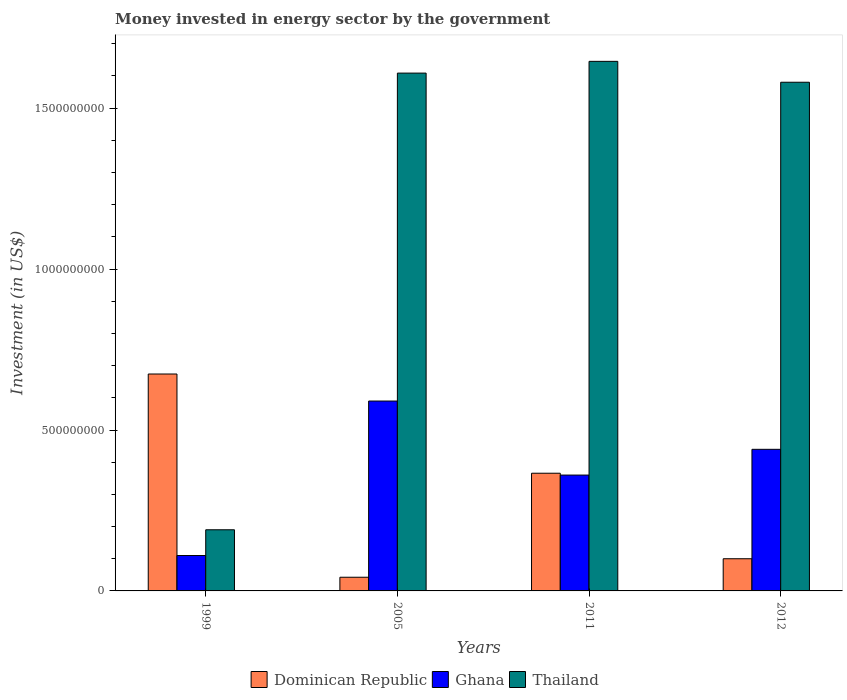How many different coloured bars are there?
Ensure brevity in your answer.  3. How many groups of bars are there?
Make the answer very short. 4. Are the number of bars on each tick of the X-axis equal?
Your response must be concise. Yes. In how many cases, is the number of bars for a given year not equal to the number of legend labels?
Make the answer very short. 0. What is the money spent in energy sector in Thailand in 1999?
Keep it short and to the point. 1.90e+08. Across all years, what is the maximum money spent in energy sector in Ghana?
Your answer should be compact. 5.90e+08. Across all years, what is the minimum money spent in energy sector in Dominican Republic?
Provide a succinct answer. 4.25e+07. In which year was the money spent in energy sector in Dominican Republic minimum?
Offer a very short reply. 2005. What is the total money spent in energy sector in Thailand in the graph?
Keep it short and to the point. 5.03e+09. What is the difference between the money spent in energy sector in Thailand in 2005 and that in 2011?
Provide a short and direct response. -3.65e+07. What is the difference between the money spent in energy sector in Thailand in 2011 and the money spent in energy sector in Dominican Republic in 2012?
Make the answer very short. 1.55e+09. What is the average money spent in energy sector in Ghana per year?
Make the answer very short. 3.75e+08. In the year 2012, what is the difference between the money spent in energy sector in Ghana and money spent in energy sector in Dominican Republic?
Give a very brief answer. 3.40e+08. What is the ratio of the money spent in energy sector in Ghana in 2011 to that in 2012?
Give a very brief answer. 0.82. Is the money spent in energy sector in Dominican Republic in 2005 less than that in 2011?
Make the answer very short. Yes. What is the difference between the highest and the second highest money spent in energy sector in Dominican Republic?
Ensure brevity in your answer.  3.08e+08. What is the difference between the highest and the lowest money spent in energy sector in Ghana?
Ensure brevity in your answer.  4.80e+08. Is the sum of the money spent in energy sector in Thailand in 1999 and 2011 greater than the maximum money spent in energy sector in Ghana across all years?
Give a very brief answer. Yes. What does the 3rd bar from the left in 1999 represents?
Your answer should be compact. Thailand. What does the 1st bar from the right in 2012 represents?
Your answer should be compact. Thailand. Are all the bars in the graph horizontal?
Keep it short and to the point. No. How many years are there in the graph?
Give a very brief answer. 4. What is the difference between two consecutive major ticks on the Y-axis?
Keep it short and to the point. 5.00e+08. Does the graph contain grids?
Your answer should be compact. No. Where does the legend appear in the graph?
Your answer should be compact. Bottom center. How many legend labels are there?
Provide a succinct answer. 3. What is the title of the graph?
Provide a succinct answer. Money invested in energy sector by the government. Does "Montenegro" appear as one of the legend labels in the graph?
Provide a short and direct response. No. What is the label or title of the Y-axis?
Your answer should be compact. Investment (in US$). What is the Investment (in US$) of Dominican Republic in 1999?
Ensure brevity in your answer.  6.74e+08. What is the Investment (in US$) of Ghana in 1999?
Offer a terse response. 1.10e+08. What is the Investment (in US$) of Thailand in 1999?
Ensure brevity in your answer.  1.90e+08. What is the Investment (in US$) of Dominican Republic in 2005?
Keep it short and to the point. 4.25e+07. What is the Investment (in US$) in Ghana in 2005?
Provide a succinct answer. 5.90e+08. What is the Investment (in US$) of Thailand in 2005?
Your answer should be compact. 1.61e+09. What is the Investment (in US$) in Dominican Republic in 2011?
Provide a short and direct response. 3.66e+08. What is the Investment (in US$) of Ghana in 2011?
Offer a terse response. 3.60e+08. What is the Investment (in US$) of Thailand in 2011?
Your response must be concise. 1.65e+09. What is the Investment (in US$) of Ghana in 2012?
Offer a very short reply. 4.40e+08. What is the Investment (in US$) in Thailand in 2012?
Offer a very short reply. 1.58e+09. Across all years, what is the maximum Investment (in US$) of Dominican Republic?
Your response must be concise. 6.74e+08. Across all years, what is the maximum Investment (in US$) in Ghana?
Keep it short and to the point. 5.90e+08. Across all years, what is the maximum Investment (in US$) of Thailand?
Your answer should be compact. 1.65e+09. Across all years, what is the minimum Investment (in US$) in Dominican Republic?
Give a very brief answer. 4.25e+07. Across all years, what is the minimum Investment (in US$) in Ghana?
Provide a succinct answer. 1.10e+08. Across all years, what is the minimum Investment (in US$) in Thailand?
Ensure brevity in your answer.  1.90e+08. What is the total Investment (in US$) in Dominican Republic in the graph?
Your answer should be compact. 1.18e+09. What is the total Investment (in US$) in Ghana in the graph?
Provide a succinct answer. 1.50e+09. What is the total Investment (in US$) of Thailand in the graph?
Give a very brief answer. 5.03e+09. What is the difference between the Investment (in US$) of Dominican Republic in 1999 and that in 2005?
Your response must be concise. 6.32e+08. What is the difference between the Investment (in US$) in Ghana in 1999 and that in 2005?
Offer a terse response. -4.80e+08. What is the difference between the Investment (in US$) in Thailand in 1999 and that in 2005?
Your answer should be very brief. -1.42e+09. What is the difference between the Investment (in US$) in Dominican Republic in 1999 and that in 2011?
Keep it short and to the point. 3.08e+08. What is the difference between the Investment (in US$) of Ghana in 1999 and that in 2011?
Give a very brief answer. -2.50e+08. What is the difference between the Investment (in US$) of Thailand in 1999 and that in 2011?
Give a very brief answer. -1.46e+09. What is the difference between the Investment (in US$) of Dominican Republic in 1999 and that in 2012?
Ensure brevity in your answer.  5.74e+08. What is the difference between the Investment (in US$) of Ghana in 1999 and that in 2012?
Keep it short and to the point. -3.30e+08. What is the difference between the Investment (in US$) of Thailand in 1999 and that in 2012?
Give a very brief answer. -1.39e+09. What is the difference between the Investment (in US$) in Dominican Republic in 2005 and that in 2011?
Your answer should be compact. -3.23e+08. What is the difference between the Investment (in US$) in Ghana in 2005 and that in 2011?
Ensure brevity in your answer.  2.30e+08. What is the difference between the Investment (in US$) of Thailand in 2005 and that in 2011?
Give a very brief answer. -3.65e+07. What is the difference between the Investment (in US$) in Dominican Republic in 2005 and that in 2012?
Make the answer very short. -5.75e+07. What is the difference between the Investment (in US$) of Ghana in 2005 and that in 2012?
Offer a terse response. 1.50e+08. What is the difference between the Investment (in US$) of Thailand in 2005 and that in 2012?
Provide a succinct answer. 2.84e+07. What is the difference between the Investment (in US$) in Dominican Republic in 2011 and that in 2012?
Provide a succinct answer. 2.66e+08. What is the difference between the Investment (in US$) in Ghana in 2011 and that in 2012?
Make the answer very short. -8.00e+07. What is the difference between the Investment (in US$) in Thailand in 2011 and that in 2012?
Provide a short and direct response. 6.49e+07. What is the difference between the Investment (in US$) of Dominican Republic in 1999 and the Investment (in US$) of Ghana in 2005?
Make the answer very short. 8.40e+07. What is the difference between the Investment (in US$) of Dominican Republic in 1999 and the Investment (in US$) of Thailand in 2005?
Keep it short and to the point. -9.35e+08. What is the difference between the Investment (in US$) of Ghana in 1999 and the Investment (in US$) of Thailand in 2005?
Your response must be concise. -1.50e+09. What is the difference between the Investment (in US$) of Dominican Republic in 1999 and the Investment (in US$) of Ghana in 2011?
Provide a short and direct response. 3.14e+08. What is the difference between the Investment (in US$) of Dominican Republic in 1999 and the Investment (in US$) of Thailand in 2011?
Your answer should be very brief. -9.72e+08. What is the difference between the Investment (in US$) of Ghana in 1999 and the Investment (in US$) of Thailand in 2011?
Your response must be concise. -1.54e+09. What is the difference between the Investment (in US$) of Dominican Republic in 1999 and the Investment (in US$) of Ghana in 2012?
Offer a terse response. 2.34e+08. What is the difference between the Investment (in US$) in Dominican Republic in 1999 and the Investment (in US$) in Thailand in 2012?
Make the answer very short. -9.07e+08. What is the difference between the Investment (in US$) of Ghana in 1999 and the Investment (in US$) of Thailand in 2012?
Provide a short and direct response. -1.47e+09. What is the difference between the Investment (in US$) in Dominican Republic in 2005 and the Investment (in US$) in Ghana in 2011?
Give a very brief answer. -3.18e+08. What is the difference between the Investment (in US$) of Dominican Republic in 2005 and the Investment (in US$) of Thailand in 2011?
Make the answer very short. -1.60e+09. What is the difference between the Investment (in US$) of Ghana in 2005 and the Investment (in US$) of Thailand in 2011?
Make the answer very short. -1.06e+09. What is the difference between the Investment (in US$) of Dominican Republic in 2005 and the Investment (in US$) of Ghana in 2012?
Offer a terse response. -3.98e+08. What is the difference between the Investment (in US$) in Dominican Republic in 2005 and the Investment (in US$) in Thailand in 2012?
Make the answer very short. -1.54e+09. What is the difference between the Investment (in US$) of Ghana in 2005 and the Investment (in US$) of Thailand in 2012?
Offer a terse response. -9.91e+08. What is the difference between the Investment (in US$) in Dominican Republic in 2011 and the Investment (in US$) in Ghana in 2012?
Offer a terse response. -7.43e+07. What is the difference between the Investment (in US$) of Dominican Republic in 2011 and the Investment (in US$) of Thailand in 2012?
Offer a very short reply. -1.21e+09. What is the difference between the Investment (in US$) of Ghana in 2011 and the Investment (in US$) of Thailand in 2012?
Ensure brevity in your answer.  -1.22e+09. What is the average Investment (in US$) of Dominican Republic per year?
Give a very brief answer. 2.96e+08. What is the average Investment (in US$) in Ghana per year?
Your answer should be compact. 3.75e+08. What is the average Investment (in US$) of Thailand per year?
Your answer should be compact. 1.26e+09. In the year 1999, what is the difference between the Investment (in US$) in Dominican Republic and Investment (in US$) in Ghana?
Provide a short and direct response. 5.64e+08. In the year 1999, what is the difference between the Investment (in US$) of Dominican Republic and Investment (in US$) of Thailand?
Provide a succinct answer. 4.84e+08. In the year 1999, what is the difference between the Investment (in US$) of Ghana and Investment (in US$) of Thailand?
Make the answer very short. -8.00e+07. In the year 2005, what is the difference between the Investment (in US$) in Dominican Republic and Investment (in US$) in Ghana?
Provide a succinct answer. -5.48e+08. In the year 2005, what is the difference between the Investment (in US$) in Dominican Republic and Investment (in US$) in Thailand?
Make the answer very short. -1.57e+09. In the year 2005, what is the difference between the Investment (in US$) in Ghana and Investment (in US$) in Thailand?
Offer a very short reply. -1.02e+09. In the year 2011, what is the difference between the Investment (in US$) of Dominican Republic and Investment (in US$) of Ghana?
Make the answer very short. 5.70e+06. In the year 2011, what is the difference between the Investment (in US$) of Dominican Republic and Investment (in US$) of Thailand?
Your response must be concise. -1.28e+09. In the year 2011, what is the difference between the Investment (in US$) in Ghana and Investment (in US$) in Thailand?
Ensure brevity in your answer.  -1.29e+09. In the year 2012, what is the difference between the Investment (in US$) of Dominican Republic and Investment (in US$) of Ghana?
Make the answer very short. -3.40e+08. In the year 2012, what is the difference between the Investment (in US$) of Dominican Republic and Investment (in US$) of Thailand?
Give a very brief answer. -1.48e+09. In the year 2012, what is the difference between the Investment (in US$) of Ghana and Investment (in US$) of Thailand?
Provide a short and direct response. -1.14e+09. What is the ratio of the Investment (in US$) of Dominican Republic in 1999 to that in 2005?
Give a very brief answer. 15.86. What is the ratio of the Investment (in US$) in Ghana in 1999 to that in 2005?
Your response must be concise. 0.19. What is the ratio of the Investment (in US$) in Thailand in 1999 to that in 2005?
Make the answer very short. 0.12. What is the ratio of the Investment (in US$) in Dominican Republic in 1999 to that in 2011?
Give a very brief answer. 1.84. What is the ratio of the Investment (in US$) of Ghana in 1999 to that in 2011?
Offer a very short reply. 0.31. What is the ratio of the Investment (in US$) in Thailand in 1999 to that in 2011?
Offer a terse response. 0.12. What is the ratio of the Investment (in US$) of Dominican Republic in 1999 to that in 2012?
Give a very brief answer. 6.74. What is the ratio of the Investment (in US$) of Ghana in 1999 to that in 2012?
Your response must be concise. 0.25. What is the ratio of the Investment (in US$) in Thailand in 1999 to that in 2012?
Give a very brief answer. 0.12. What is the ratio of the Investment (in US$) of Dominican Republic in 2005 to that in 2011?
Your response must be concise. 0.12. What is the ratio of the Investment (in US$) in Ghana in 2005 to that in 2011?
Make the answer very short. 1.64. What is the ratio of the Investment (in US$) of Thailand in 2005 to that in 2011?
Keep it short and to the point. 0.98. What is the ratio of the Investment (in US$) in Dominican Republic in 2005 to that in 2012?
Offer a very short reply. 0.42. What is the ratio of the Investment (in US$) of Ghana in 2005 to that in 2012?
Provide a succinct answer. 1.34. What is the ratio of the Investment (in US$) in Thailand in 2005 to that in 2012?
Your answer should be compact. 1.02. What is the ratio of the Investment (in US$) in Dominican Republic in 2011 to that in 2012?
Your response must be concise. 3.66. What is the ratio of the Investment (in US$) of Ghana in 2011 to that in 2012?
Offer a very short reply. 0.82. What is the ratio of the Investment (in US$) in Thailand in 2011 to that in 2012?
Offer a very short reply. 1.04. What is the difference between the highest and the second highest Investment (in US$) in Dominican Republic?
Your response must be concise. 3.08e+08. What is the difference between the highest and the second highest Investment (in US$) of Ghana?
Ensure brevity in your answer.  1.50e+08. What is the difference between the highest and the second highest Investment (in US$) in Thailand?
Keep it short and to the point. 3.65e+07. What is the difference between the highest and the lowest Investment (in US$) of Dominican Republic?
Provide a short and direct response. 6.32e+08. What is the difference between the highest and the lowest Investment (in US$) of Ghana?
Offer a very short reply. 4.80e+08. What is the difference between the highest and the lowest Investment (in US$) in Thailand?
Offer a terse response. 1.46e+09. 